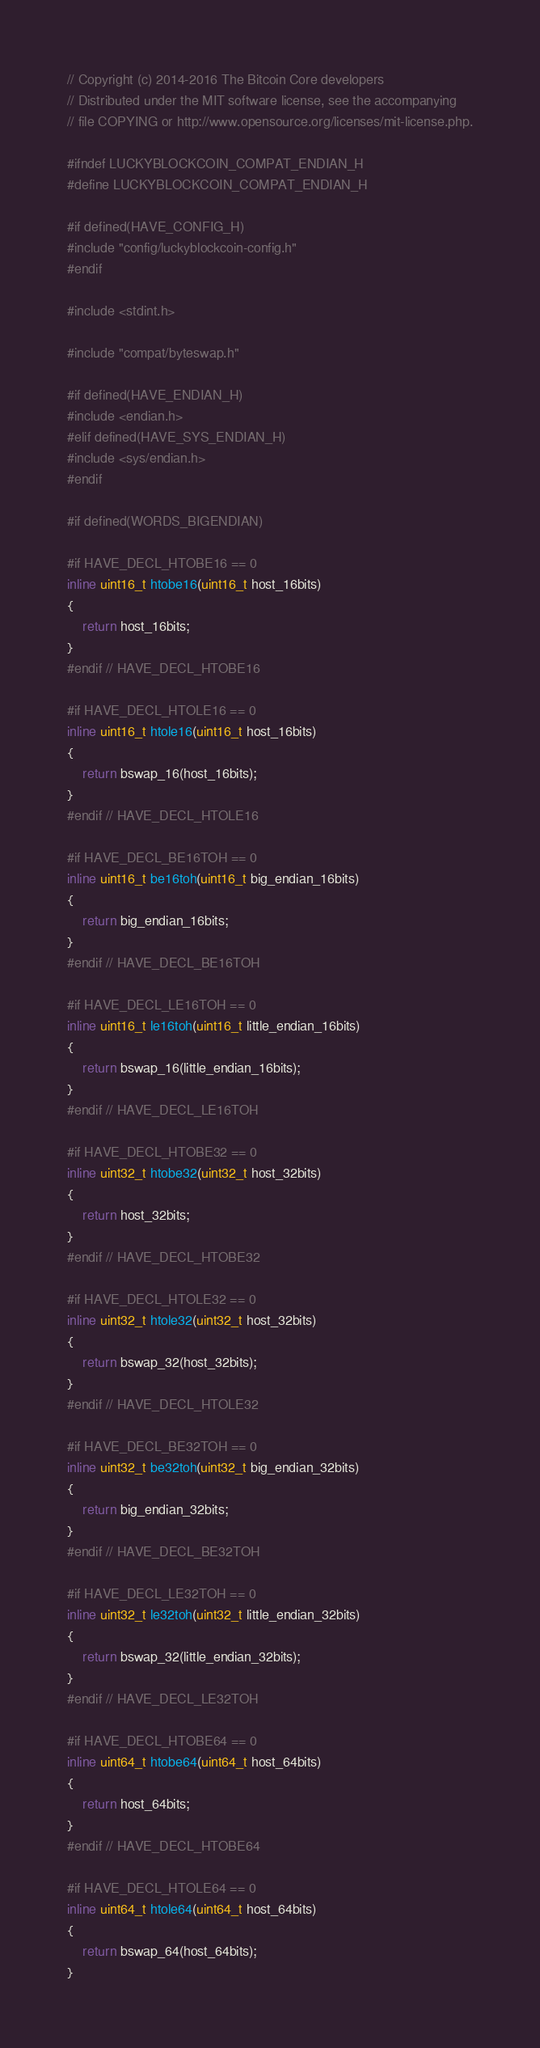Convert code to text. <code><loc_0><loc_0><loc_500><loc_500><_C_>// Copyright (c) 2014-2016 The Bitcoin Core developers
// Distributed under the MIT software license, see the accompanying
// file COPYING or http://www.opensource.org/licenses/mit-license.php.

#ifndef LUCKYBLOCKCOIN_COMPAT_ENDIAN_H
#define LUCKYBLOCKCOIN_COMPAT_ENDIAN_H

#if defined(HAVE_CONFIG_H)
#include "config/luckyblockcoin-config.h"
#endif

#include <stdint.h>

#include "compat/byteswap.h"

#if defined(HAVE_ENDIAN_H)
#include <endian.h>
#elif defined(HAVE_SYS_ENDIAN_H)
#include <sys/endian.h>
#endif

#if defined(WORDS_BIGENDIAN)

#if HAVE_DECL_HTOBE16 == 0
inline uint16_t htobe16(uint16_t host_16bits)
{
    return host_16bits;
}
#endif // HAVE_DECL_HTOBE16

#if HAVE_DECL_HTOLE16 == 0
inline uint16_t htole16(uint16_t host_16bits)
{
    return bswap_16(host_16bits);
}
#endif // HAVE_DECL_HTOLE16

#if HAVE_DECL_BE16TOH == 0
inline uint16_t be16toh(uint16_t big_endian_16bits)
{
    return big_endian_16bits;
}
#endif // HAVE_DECL_BE16TOH

#if HAVE_DECL_LE16TOH == 0
inline uint16_t le16toh(uint16_t little_endian_16bits)
{
    return bswap_16(little_endian_16bits);
}
#endif // HAVE_DECL_LE16TOH

#if HAVE_DECL_HTOBE32 == 0
inline uint32_t htobe32(uint32_t host_32bits)
{
    return host_32bits;
}
#endif // HAVE_DECL_HTOBE32

#if HAVE_DECL_HTOLE32 == 0
inline uint32_t htole32(uint32_t host_32bits)
{
    return bswap_32(host_32bits);
}
#endif // HAVE_DECL_HTOLE32

#if HAVE_DECL_BE32TOH == 0
inline uint32_t be32toh(uint32_t big_endian_32bits)
{
    return big_endian_32bits;
}
#endif // HAVE_DECL_BE32TOH

#if HAVE_DECL_LE32TOH == 0
inline uint32_t le32toh(uint32_t little_endian_32bits)
{
    return bswap_32(little_endian_32bits);
}
#endif // HAVE_DECL_LE32TOH

#if HAVE_DECL_HTOBE64 == 0
inline uint64_t htobe64(uint64_t host_64bits)
{
    return host_64bits;
}
#endif // HAVE_DECL_HTOBE64

#if HAVE_DECL_HTOLE64 == 0
inline uint64_t htole64(uint64_t host_64bits)
{
    return bswap_64(host_64bits);
}</code> 